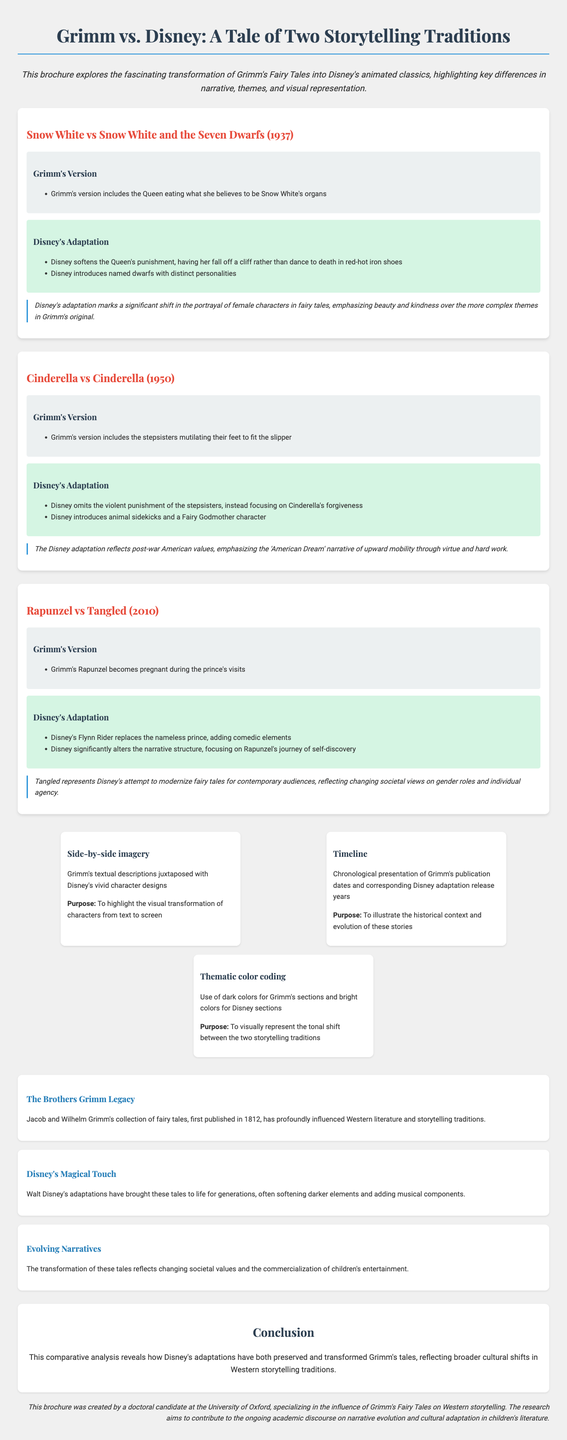what is the title of the brochure? The title is presented at the top of the document, emphasizing the comparison between Grimm's Fairy Tales and Disney adaptations.
Answer: Grimm vs. Disney: A Tale of Two Storytelling Traditions how many Grimm's tales are compared in the brochure? The brochure includes a section comparing three specific Grimm's tales to their Disney adaptations.
Answer: 3 what is the publication year of Grimm's Fairy Tales? This information is provided in the text box discussing The Brothers Grimm Legacy.
Answer: 1812 what visual element uses dark colors? The thematic color-coding is a visual feature that uses contrasting colors to represent different storytelling traditions.
Answer: Grimm's sections which Disney adaptation was released in 1937? This detail is part of the comparison section outlining the specific adaptations of Grimm's tales.
Answer: Snow White and the Seven Dwarfs what key difference is highlighted for Disney's Cinderella? This difference showcases a significant alteration in character dynamics compared to the original tale.
Answer: omits the violent punishment of the stepsisters what is the academic insight for Tangled? Each comparison section includes an academic insight that reflects on the cultural implications of the adaptations.
Answer: reflects changing societal views on gender roles and individual agency who created this brochure? The author of the brochure is mentioned at the end, providing information about their academic affiliation.
Answer: a doctoral candidate at the University of Oxford what does the timeline visual element illustrate? The timeline provides historical context related to the adaptations being discussed.
Answer: the evolution of these stories 